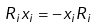Convert formula to latex. <formula><loc_0><loc_0><loc_500><loc_500>R _ { i } x _ { i } = - x _ { i } R _ { i }</formula> 